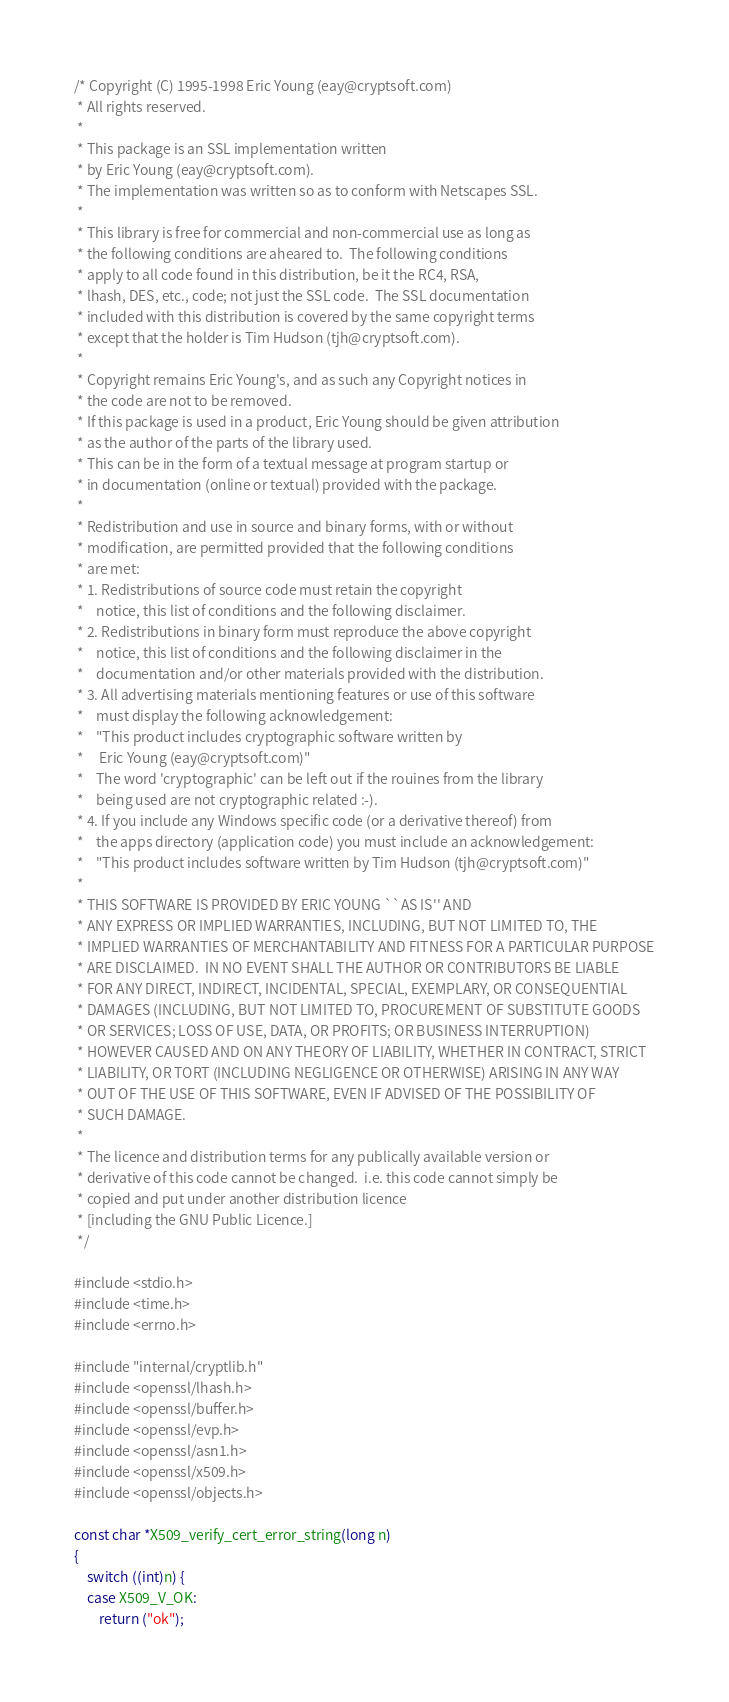Convert code to text. <code><loc_0><loc_0><loc_500><loc_500><_C_>/* Copyright (C) 1995-1998 Eric Young (eay@cryptsoft.com)
 * All rights reserved.
 *
 * This package is an SSL implementation written
 * by Eric Young (eay@cryptsoft.com).
 * The implementation was written so as to conform with Netscapes SSL.
 *
 * This library is free for commercial and non-commercial use as long as
 * the following conditions are aheared to.  The following conditions
 * apply to all code found in this distribution, be it the RC4, RSA,
 * lhash, DES, etc., code; not just the SSL code.  The SSL documentation
 * included with this distribution is covered by the same copyright terms
 * except that the holder is Tim Hudson (tjh@cryptsoft.com).
 *
 * Copyright remains Eric Young's, and as such any Copyright notices in
 * the code are not to be removed.
 * If this package is used in a product, Eric Young should be given attribution
 * as the author of the parts of the library used.
 * This can be in the form of a textual message at program startup or
 * in documentation (online or textual) provided with the package.
 *
 * Redistribution and use in source and binary forms, with or without
 * modification, are permitted provided that the following conditions
 * are met:
 * 1. Redistributions of source code must retain the copyright
 *    notice, this list of conditions and the following disclaimer.
 * 2. Redistributions in binary form must reproduce the above copyright
 *    notice, this list of conditions and the following disclaimer in the
 *    documentation and/or other materials provided with the distribution.
 * 3. All advertising materials mentioning features or use of this software
 *    must display the following acknowledgement:
 *    "This product includes cryptographic software written by
 *     Eric Young (eay@cryptsoft.com)"
 *    The word 'cryptographic' can be left out if the rouines from the library
 *    being used are not cryptographic related :-).
 * 4. If you include any Windows specific code (or a derivative thereof) from
 *    the apps directory (application code) you must include an acknowledgement:
 *    "This product includes software written by Tim Hudson (tjh@cryptsoft.com)"
 *
 * THIS SOFTWARE IS PROVIDED BY ERIC YOUNG ``AS IS'' AND
 * ANY EXPRESS OR IMPLIED WARRANTIES, INCLUDING, BUT NOT LIMITED TO, THE
 * IMPLIED WARRANTIES OF MERCHANTABILITY AND FITNESS FOR A PARTICULAR PURPOSE
 * ARE DISCLAIMED.  IN NO EVENT SHALL THE AUTHOR OR CONTRIBUTORS BE LIABLE
 * FOR ANY DIRECT, INDIRECT, INCIDENTAL, SPECIAL, EXEMPLARY, OR CONSEQUENTIAL
 * DAMAGES (INCLUDING, BUT NOT LIMITED TO, PROCUREMENT OF SUBSTITUTE GOODS
 * OR SERVICES; LOSS OF USE, DATA, OR PROFITS; OR BUSINESS INTERRUPTION)
 * HOWEVER CAUSED AND ON ANY THEORY OF LIABILITY, WHETHER IN CONTRACT, STRICT
 * LIABILITY, OR TORT (INCLUDING NEGLIGENCE OR OTHERWISE) ARISING IN ANY WAY
 * OUT OF THE USE OF THIS SOFTWARE, EVEN IF ADVISED OF THE POSSIBILITY OF
 * SUCH DAMAGE.
 *
 * The licence and distribution terms for any publically available version or
 * derivative of this code cannot be changed.  i.e. this code cannot simply be
 * copied and put under another distribution licence
 * [including the GNU Public Licence.]
 */

#include <stdio.h>
#include <time.h>
#include <errno.h>

#include "internal/cryptlib.h"
#include <openssl/lhash.h>
#include <openssl/buffer.h>
#include <openssl/evp.h>
#include <openssl/asn1.h>
#include <openssl/x509.h>
#include <openssl/objects.h>

const char *X509_verify_cert_error_string(long n)
{
    switch ((int)n) {
    case X509_V_OK:
        return ("ok");</code> 